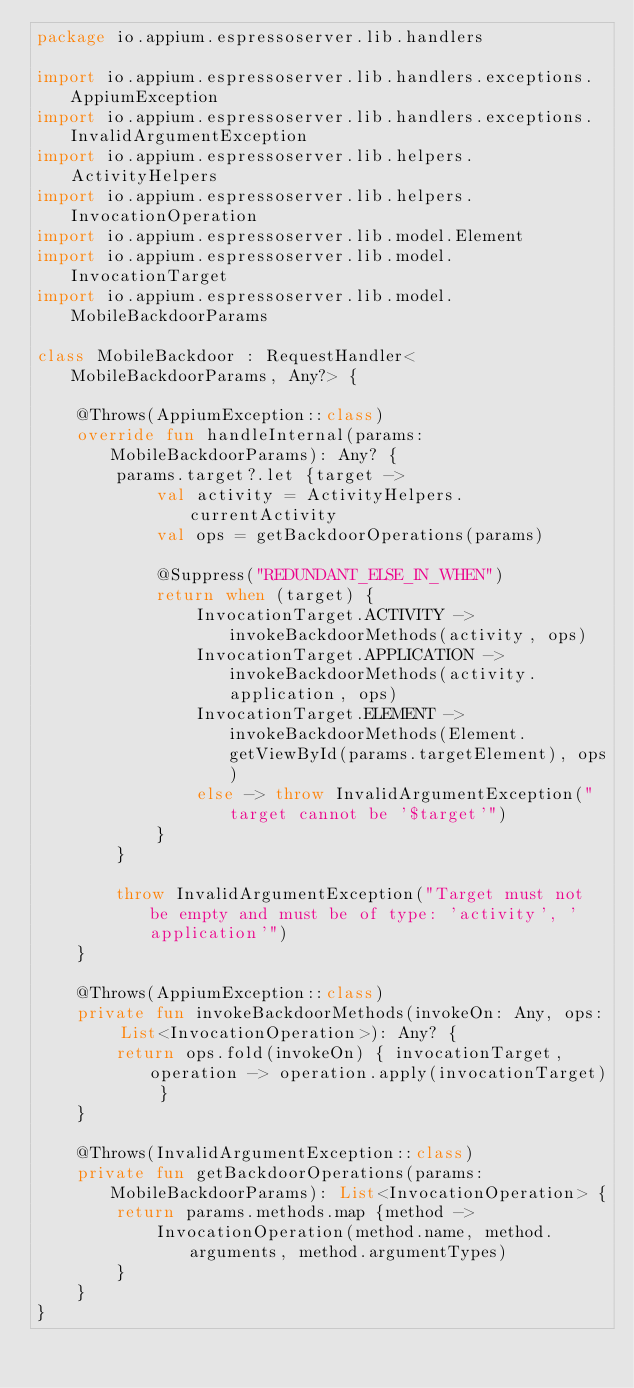Convert code to text. <code><loc_0><loc_0><loc_500><loc_500><_Kotlin_>package io.appium.espressoserver.lib.handlers

import io.appium.espressoserver.lib.handlers.exceptions.AppiumException
import io.appium.espressoserver.lib.handlers.exceptions.InvalidArgumentException
import io.appium.espressoserver.lib.helpers.ActivityHelpers
import io.appium.espressoserver.lib.helpers.InvocationOperation
import io.appium.espressoserver.lib.model.Element
import io.appium.espressoserver.lib.model.InvocationTarget
import io.appium.espressoserver.lib.model.MobileBackdoorParams

class MobileBackdoor : RequestHandler<MobileBackdoorParams, Any?> {

    @Throws(AppiumException::class)
    override fun handleInternal(params: MobileBackdoorParams): Any? {
        params.target?.let {target ->
            val activity = ActivityHelpers.currentActivity
            val ops = getBackdoorOperations(params)

            @Suppress("REDUNDANT_ELSE_IN_WHEN")
            return when (target) {
                InvocationTarget.ACTIVITY -> invokeBackdoorMethods(activity, ops)
                InvocationTarget.APPLICATION -> invokeBackdoorMethods(activity.application, ops)
                InvocationTarget.ELEMENT -> invokeBackdoorMethods(Element.getViewById(params.targetElement), ops)
                else -> throw InvalidArgumentException("target cannot be '$target'")
            }
        }

        throw InvalidArgumentException("Target must not be empty and must be of type: 'activity', 'application'")
    }

    @Throws(AppiumException::class)
    private fun invokeBackdoorMethods(invokeOn: Any, ops: List<InvocationOperation>): Any? {
        return ops.fold(invokeOn) { invocationTarget, operation -> operation.apply(invocationTarget) }
    }

    @Throws(InvalidArgumentException::class)
    private fun getBackdoorOperations(params: MobileBackdoorParams): List<InvocationOperation> {
        return params.methods.map {method ->
            InvocationOperation(method.name, method.arguments, method.argumentTypes)
        }
    }
}
</code> 